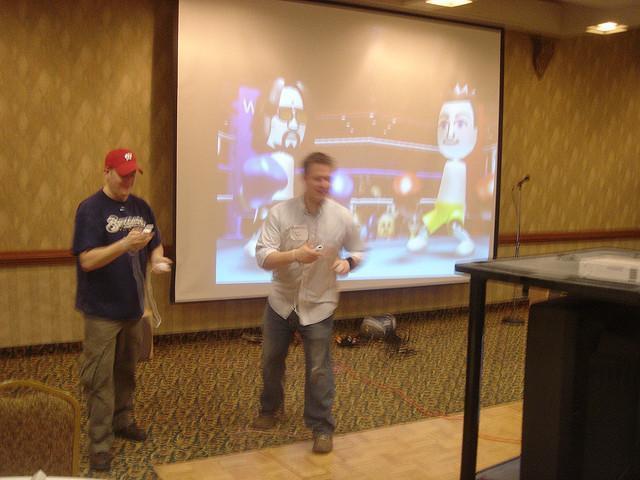Which player is controlling the avatar with the blue gloves?
From the following four choices, select the correct answer to address the question.
Options: Black shirt, off screen, dress shirt, blue jeans. Black shirt. 